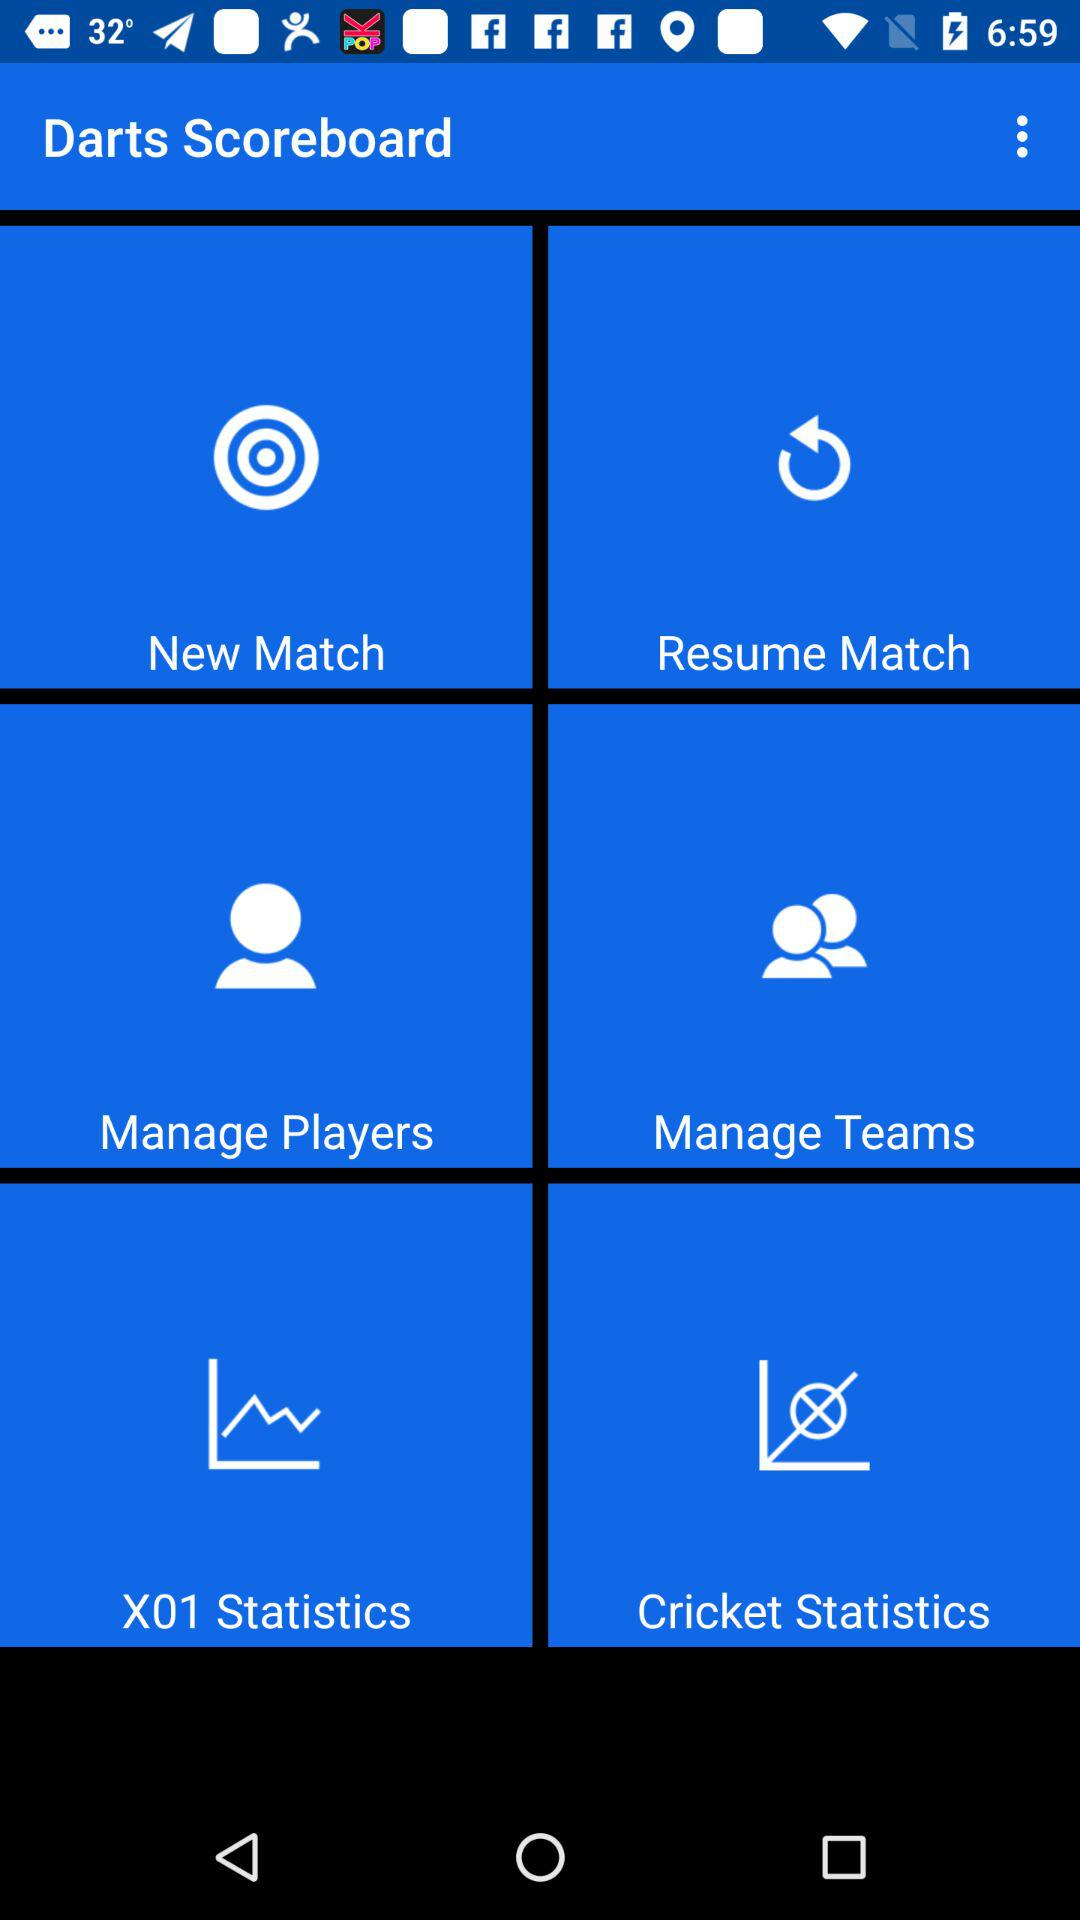What is the application name? The application name is "Darts Scoreboard". 